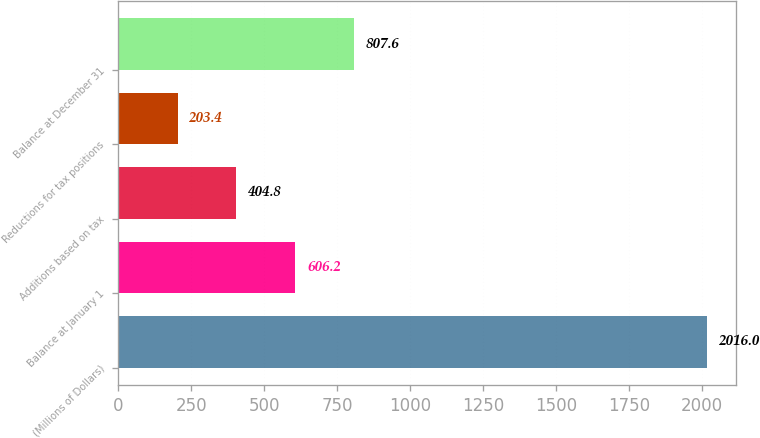Convert chart to OTSL. <chart><loc_0><loc_0><loc_500><loc_500><bar_chart><fcel>(Millions of Dollars)<fcel>Balance at January 1<fcel>Additions based on tax<fcel>Reductions for tax positions<fcel>Balance at December 31<nl><fcel>2016<fcel>606.2<fcel>404.8<fcel>203.4<fcel>807.6<nl></chart> 